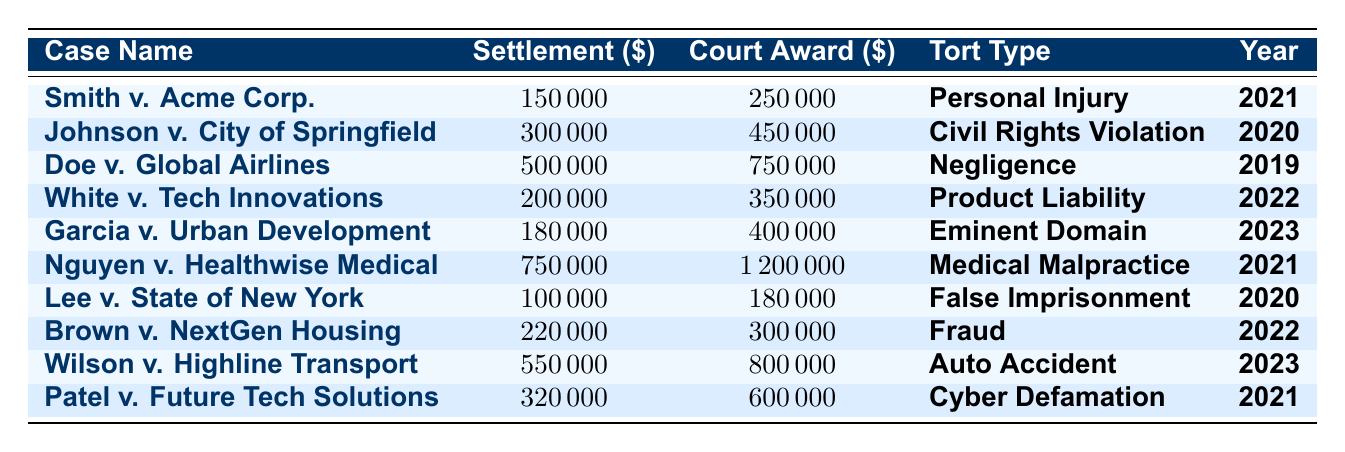What is the highest court-awarded damages listed in the table? The highest court-awarded damages can be found by scanning through the 'Court Award' column. The largest value is 1,200,000 from the case Nguyen v. Healthwise Medical.
Answer: 1,200,000 What is the total amount of settlement amounts for all cases in 2021? To find the total settlement amount for 2021, we sum the settlement amounts for the cases in that year: Smith v. Acme Corp. (150,000) + Nguyen v. Healthwise Medical (750,000) + Patel v. Future Tech Solutions (320,000). The total is 150,000 + 750,000 + 320,000 = 1,220,000.
Answer: 1,220,000 In which case was the difference between court-awarded damages and settlement amount the largest? We need to calculate the difference for each case by subtracting the settlement amount from the court-awarded damages, then compare the values: Doe v. Global Airlines (750,000 - 500,000 = 250,000) has the largest difference.
Answer: Doe v. Global Airlines Is there any case in 2020 where the settlement amount was lower than the court-awarded damages? We check the cases from 2020: Johnson v. City of Springfield (300,000 < 450,000) and Lee v. State of New York (100,000 < 180,000). Both cases have lower settlements than court-awarded damages.
Answer: Yes What is the average settlement amount for the tort type "Medical Malpractice"? There is only one case under "Medical Malpractice," Nguyen v. Healthwise Medical, with a settlement amount of 750,000. Hence, the average is 750,000/1 = 750,000.
Answer: 750,000 How many cases have settlement amounts exceeding 200,000? We review the settlement amounts: Nguyen v. Healthwise Medical (750,000), Doe v. Global Airlines (500,000), Johnson v. City of Springfield (300,000), and Wilson v. Highline Transport (550,000). There are four cases with settlements exceeding 200,000.
Answer: 4 Compare the average court-awarded damages for 2022 and 2023 and determine which year had higher damages. Calculate the average for 2022: White v. Tech Innovations (350,000) + Brown v. NextGen Housing (300,000) gives 650,000/2 = 325,000. For 2023: Garcia v. Urban Development (400,000) + Wilson v. Highline Transport (800,000) gives 1,200,000/2 = 600,000. Comparing, 600,000 (2023) > 325,000 (2022).
Answer: 2023 had higher damages What percentage of the total court-awarded damages is represented by the case "Smith v. Acme Corp."? First, sum all court-awarded damages: 250,000 + 450,000 + 750,000 + 350,000 + 400,000 + 1,200,000 + 180,000 + 300,000 + 800,000 + 600,000 = 4,030,000. Then calculate the percentage: (250,000 / 4,030,000) * 100 ≈ 6.20%.
Answer: 6.20% 